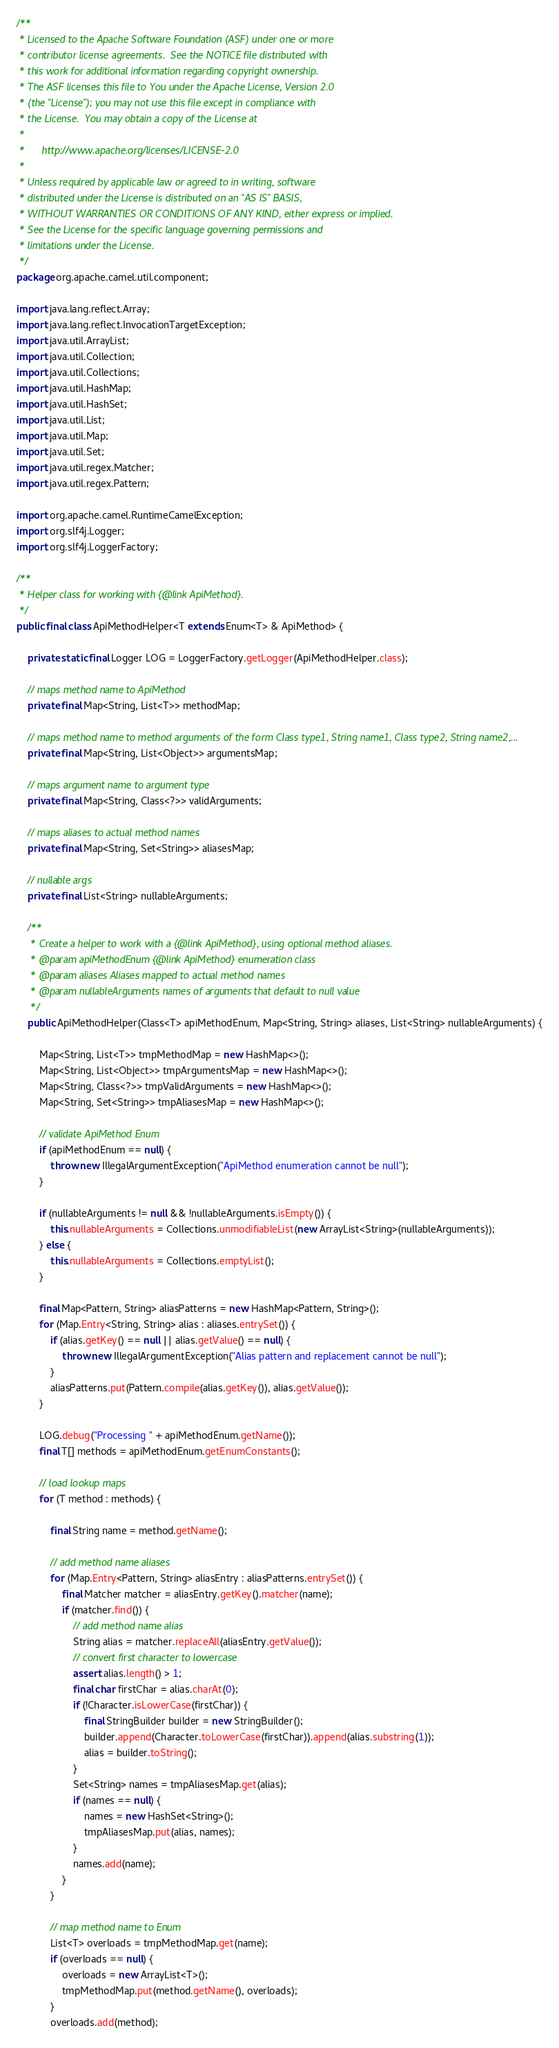Convert code to text. <code><loc_0><loc_0><loc_500><loc_500><_Java_>/**
 * Licensed to the Apache Software Foundation (ASF) under one or more
 * contributor license agreements.  See the NOTICE file distributed with
 * this work for additional information regarding copyright ownership.
 * The ASF licenses this file to You under the Apache License, Version 2.0
 * (the "License"); you may not use this file except in compliance with
 * the License.  You may obtain a copy of the License at
 *
 *      http://www.apache.org/licenses/LICENSE-2.0
 *
 * Unless required by applicable law or agreed to in writing, software
 * distributed under the License is distributed on an "AS IS" BASIS,
 * WITHOUT WARRANTIES OR CONDITIONS OF ANY KIND, either express or implied.
 * See the License for the specific language governing permissions and
 * limitations under the License.
 */
package org.apache.camel.util.component;

import java.lang.reflect.Array;
import java.lang.reflect.InvocationTargetException;
import java.util.ArrayList;
import java.util.Collection;
import java.util.Collections;
import java.util.HashMap;
import java.util.HashSet;
import java.util.List;
import java.util.Map;
import java.util.Set;
import java.util.regex.Matcher;
import java.util.regex.Pattern;

import org.apache.camel.RuntimeCamelException;
import org.slf4j.Logger;
import org.slf4j.LoggerFactory;

/**
 * Helper class for working with {@link ApiMethod}.
 */
public final class ApiMethodHelper<T extends Enum<T> & ApiMethod> {

    private static final Logger LOG = LoggerFactory.getLogger(ApiMethodHelper.class);

    // maps method name to ApiMethod
    private final Map<String, List<T>> methodMap;

    // maps method name to method arguments of the form Class type1, String name1, Class type2, String name2,...
    private final Map<String, List<Object>> argumentsMap;

    // maps argument name to argument type
    private final Map<String, Class<?>> validArguments;

    // maps aliases to actual method names
    private final Map<String, Set<String>> aliasesMap;

    // nullable args
    private final List<String> nullableArguments;

    /**
     * Create a helper to work with a {@link ApiMethod}, using optional method aliases.
     * @param apiMethodEnum {@link ApiMethod} enumeration class
     * @param aliases Aliases mapped to actual method names
     * @param nullableArguments names of arguments that default to null value
     */
    public ApiMethodHelper(Class<T> apiMethodEnum, Map<String, String> aliases, List<String> nullableArguments) {

        Map<String, List<T>> tmpMethodMap = new HashMap<>();
        Map<String, List<Object>> tmpArgumentsMap = new HashMap<>();
        Map<String, Class<?>> tmpValidArguments = new HashMap<>();
        Map<String, Set<String>> tmpAliasesMap = new HashMap<>();

        // validate ApiMethod Enum
        if (apiMethodEnum == null) {
            throw new IllegalArgumentException("ApiMethod enumeration cannot be null");
        }

        if (nullableArguments != null && !nullableArguments.isEmpty()) {
            this.nullableArguments = Collections.unmodifiableList(new ArrayList<String>(nullableArguments));
        } else {
            this.nullableArguments = Collections.emptyList();
        }

        final Map<Pattern, String> aliasPatterns = new HashMap<Pattern, String>();
        for (Map.Entry<String, String> alias : aliases.entrySet()) {
            if (alias.getKey() == null || alias.getValue() == null) {
                throw new IllegalArgumentException("Alias pattern and replacement cannot be null");
            }
            aliasPatterns.put(Pattern.compile(alias.getKey()), alias.getValue());
        }

        LOG.debug("Processing " + apiMethodEnum.getName());
        final T[] methods = apiMethodEnum.getEnumConstants();

        // load lookup maps
        for (T method : methods) {

            final String name = method.getName();

            // add method name aliases
            for (Map.Entry<Pattern, String> aliasEntry : aliasPatterns.entrySet()) {
                final Matcher matcher = aliasEntry.getKey().matcher(name);
                if (matcher.find()) {
                    // add method name alias
                    String alias = matcher.replaceAll(aliasEntry.getValue());
                    // convert first character to lowercase
                    assert alias.length() > 1;
                    final char firstChar = alias.charAt(0);
                    if (!Character.isLowerCase(firstChar)) {
                        final StringBuilder builder = new StringBuilder();
                        builder.append(Character.toLowerCase(firstChar)).append(alias.substring(1));
                        alias = builder.toString();
                    }
                    Set<String> names = tmpAliasesMap.get(alias);
                    if (names == null) {
                        names = new HashSet<String>();
                        tmpAliasesMap.put(alias, names);
                    }
                    names.add(name);
                }
            }

            // map method name to Enum
            List<T> overloads = tmpMethodMap.get(name);
            if (overloads == null) {
                overloads = new ArrayList<T>();
                tmpMethodMap.put(method.getName(), overloads);
            }
            overloads.add(method);
</code> 